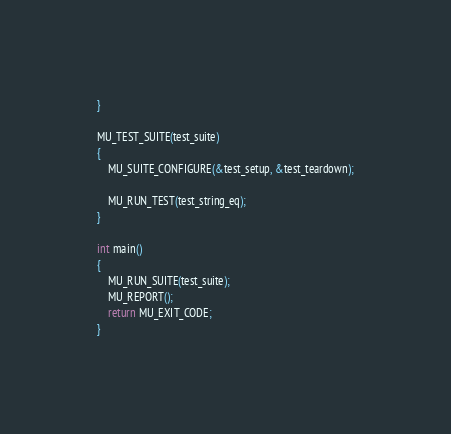<code> <loc_0><loc_0><loc_500><loc_500><_C_>}

MU_TEST_SUITE(test_suite)
{
    MU_SUITE_CONFIGURE(&test_setup, &test_teardown);

    MU_RUN_TEST(test_string_eq);
}

int main()
{
	MU_RUN_SUITE(test_suite);
	MU_REPORT();
	return MU_EXIT_CODE;
}
</code> 